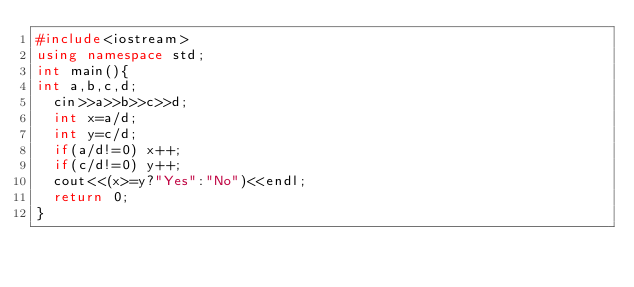<code> <loc_0><loc_0><loc_500><loc_500><_C++_>#include<iostream>
using namespace std;
int main(){
int a,b,c,d;
  cin>>a>>b>>c>>d;
  int x=a/d;
  int y=c/d;
  if(a/d!=0) x++;
  if(c/d!=0) y++;
  cout<<(x>=y?"Yes":"No")<<endl;
  return 0;
}</code> 